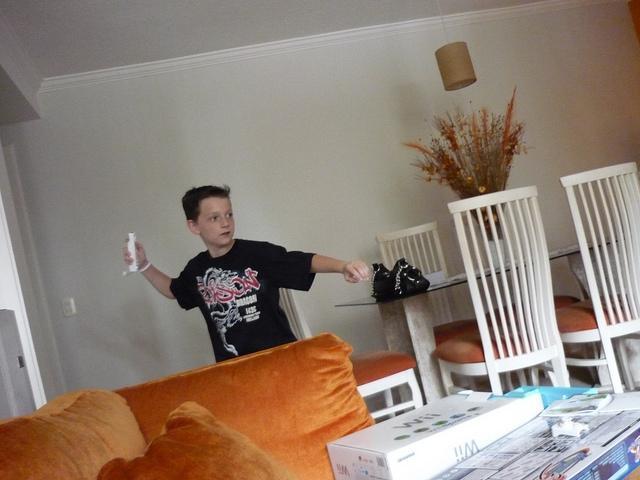How many chairs are there?
Give a very brief answer. 4. 